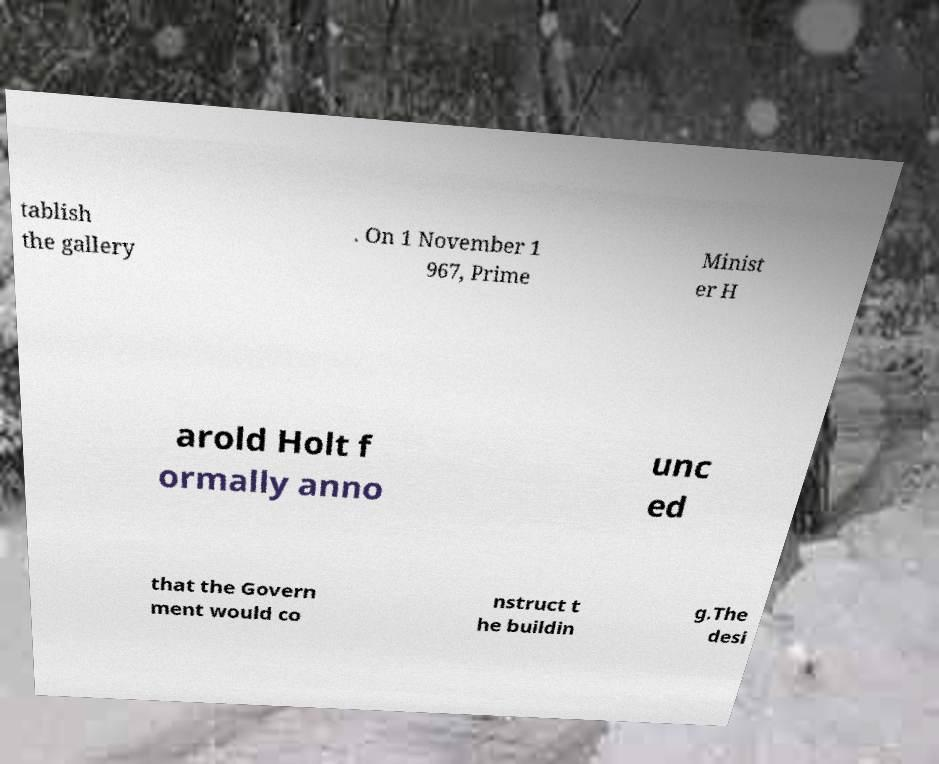Can you read and provide the text displayed in the image?This photo seems to have some interesting text. Can you extract and type it out for me? tablish the gallery . On 1 November 1 967, Prime Minist er H arold Holt f ormally anno unc ed that the Govern ment would co nstruct t he buildin g.The desi 